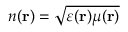Convert formula to latex. <formula><loc_0><loc_0><loc_500><loc_500>n ( r ) = \sqrt { \varepsilon ( r ) \mu ( r ) }</formula> 